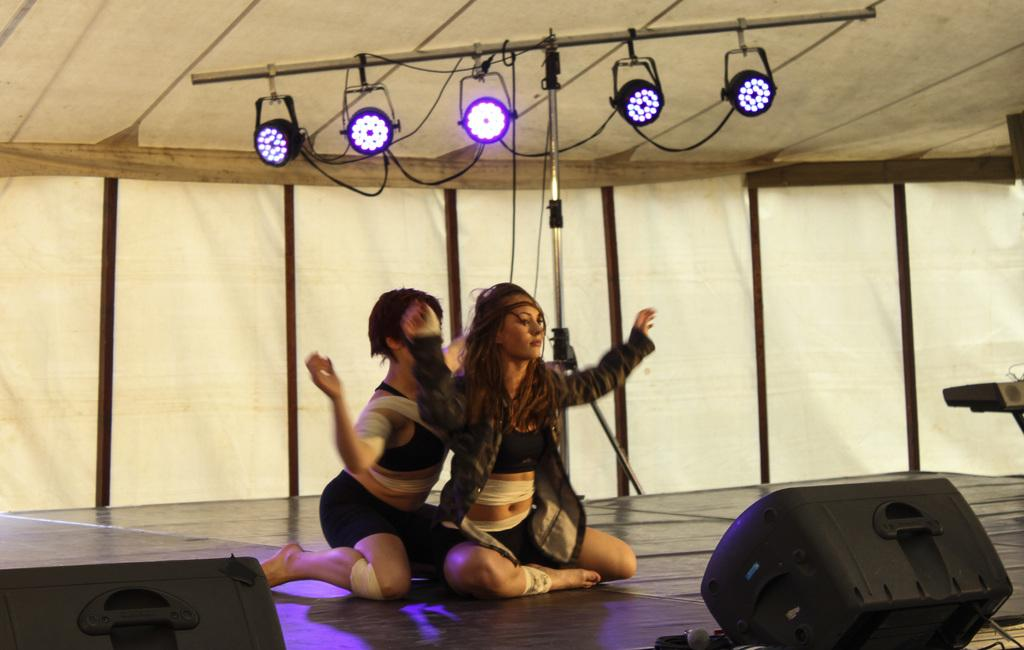How many people are present in the image? There are two people sitting in the image. What can be seen hanging from a pole in the image? There are show lights hanging from a pole. What type of setting is depicted in the image? The setting appears to be a tent. What color is the object on the stage in the image? There is a black color object on the stage. Can you tell me where the crown is located in the image? There is no crown present in the image. What type of sound can be heard coming from the receipt in the image? There is no receipt present in the image, and therefore no sound can be heard from it. 